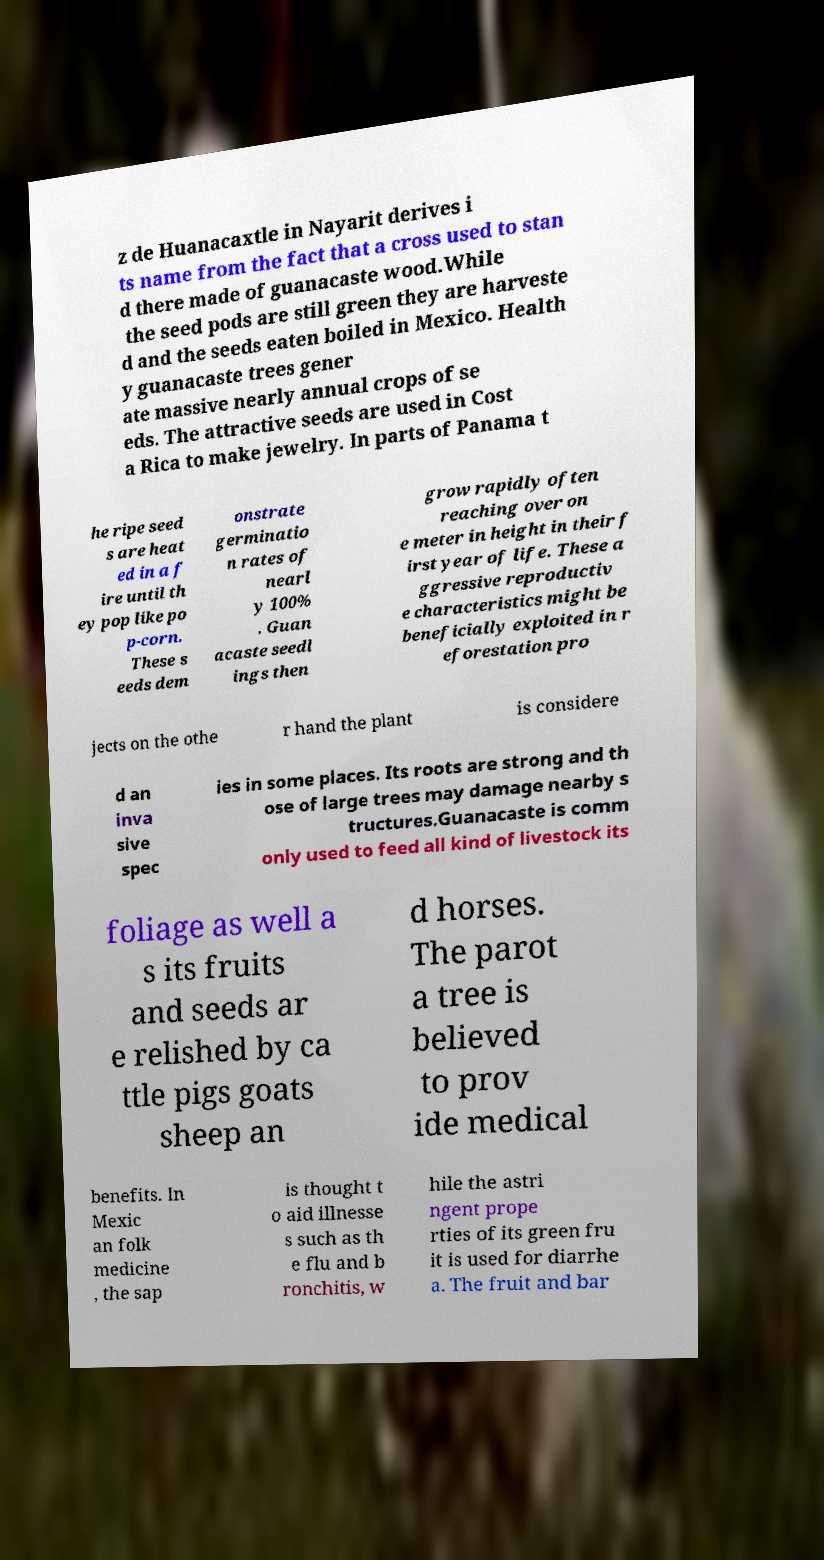Could you extract and type out the text from this image? z de Huanacaxtle in Nayarit derives i ts name from the fact that a cross used to stan d there made of guanacaste wood.While the seed pods are still green they are harveste d and the seeds eaten boiled in Mexico. Health y guanacaste trees gener ate massive nearly annual crops of se eds. The attractive seeds are used in Cost a Rica to make jewelry. In parts of Panama t he ripe seed s are heat ed in a f ire until th ey pop like po p-corn. These s eeds dem onstrate germinatio n rates of nearl y 100% . Guan acaste seedl ings then grow rapidly often reaching over on e meter in height in their f irst year of life. These a ggressive reproductiv e characteristics might be beneficially exploited in r eforestation pro jects on the othe r hand the plant is considere d an inva sive spec ies in some places. Its roots are strong and th ose of large trees may damage nearby s tructures.Guanacaste is comm only used to feed all kind of livestock its foliage as well a s its fruits and seeds ar e relished by ca ttle pigs goats sheep an d horses. The parot a tree is believed to prov ide medical benefits. In Mexic an folk medicine , the sap is thought t o aid illnesse s such as th e flu and b ronchitis, w hile the astri ngent prope rties of its green fru it is used for diarrhe a. The fruit and bar 